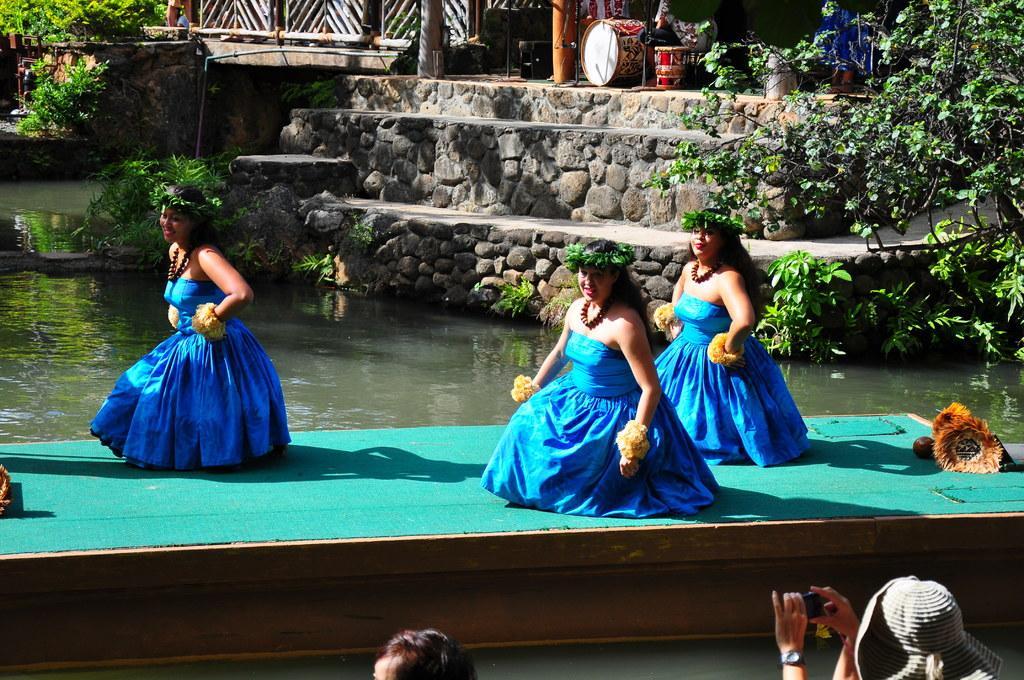In one or two sentences, can you explain what this image depicts? In the center of the image some persons are dancing on a boat. In the background of the image water is there. At the top of the image we can see stairs, pillars, speaker, drums, tree, plants, fencing are there. At the bottom right corner a person is holding camera and wearing hat. 